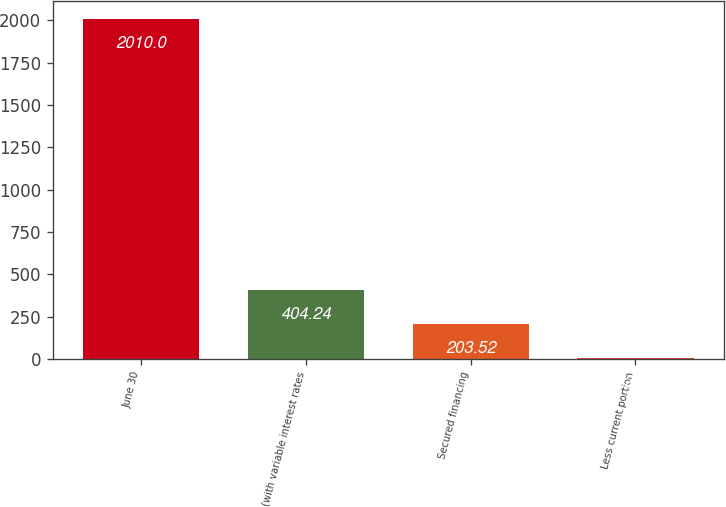<chart> <loc_0><loc_0><loc_500><loc_500><bar_chart><fcel>June 30<fcel>(with variable interest rates<fcel>Secured financing<fcel>Less current portion<nl><fcel>2010<fcel>404.24<fcel>203.52<fcel>2.8<nl></chart> 